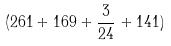<formula> <loc_0><loc_0><loc_500><loc_500>( 2 6 1 + 1 6 9 + \frac { 3 } { 2 4 } + 1 4 1 )</formula> 